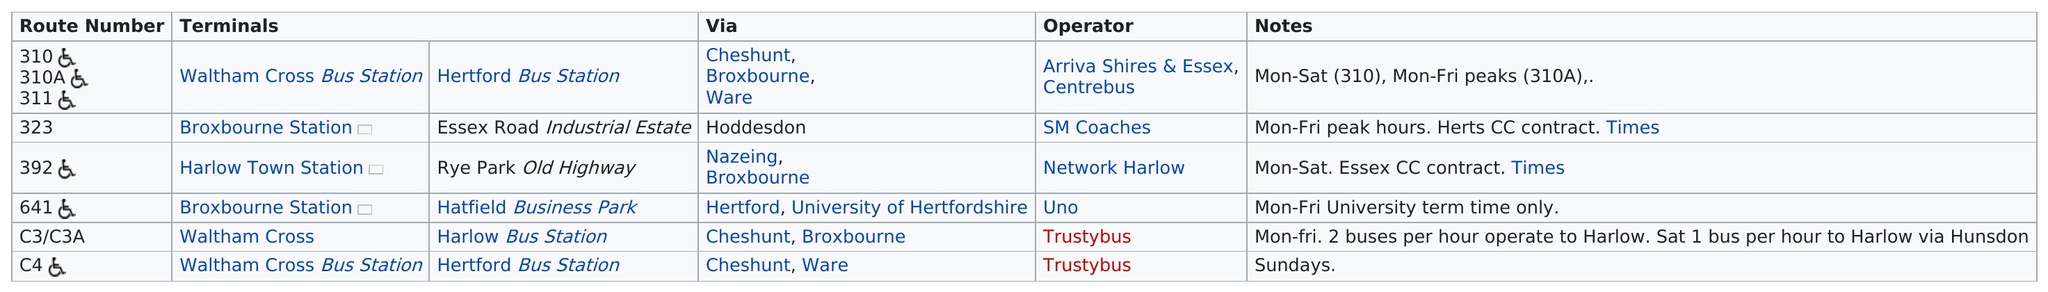Specify some key components in this picture. The route that travels to Broxbourne Station and also to the Essex Road Industrial Estate is Route 323. Trustybus handles a range of 2 bus routes. 